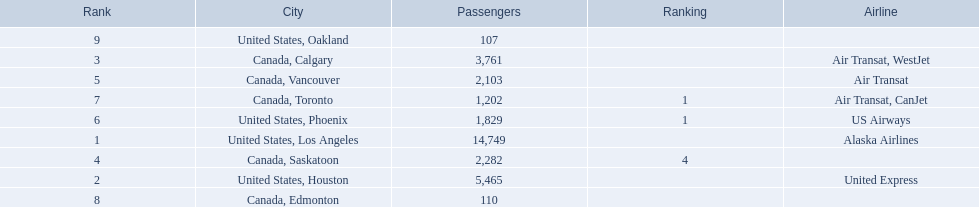What are the cities that are associated with the playa de oro international airport? United States, Los Angeles, United States, Houston, Canada, Calgary, Canada, Saskatoon, Canada, Vancouver, United States, Phoenix, Canada, Toronto, Canada, Edmonton, United States, Oakland. What is uniteed states, los angeles passenger count? 14,749. What other cities passenger count would lead to 19,000 roughly when combined with previous los angeles? Canada, Calgary. 